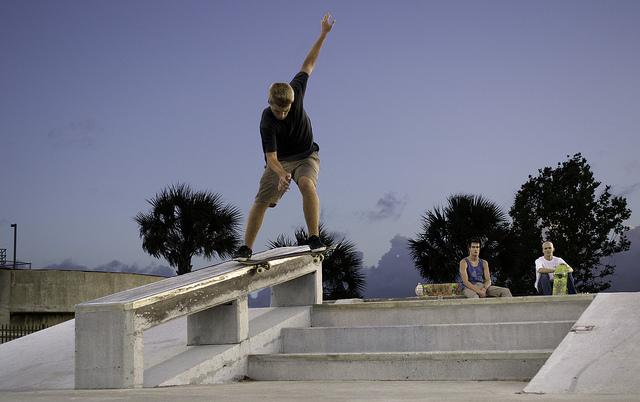What's the weather like?
Give a very brief answer. Sunny. Are the appendage arrangements seen here promoting balance or dance moves?
Quick response, please. Balance. What is the boy doing?
Quick response, please. Skateboarding. Is the guy trying to jump over the wall?
Write a very short answer. No. 